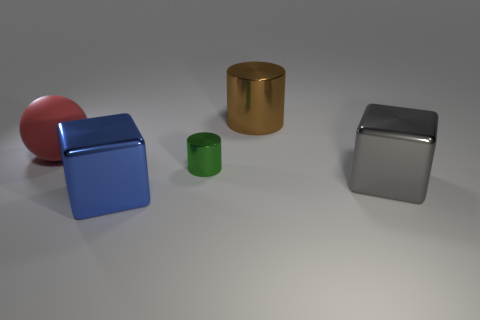Do the blue thing and the big red sphere have the same material?
Your answer should be very brief. No. Are there an equal number of gray metal blocks that are to the left of the large blue thing and red cubes?
Make the answer very short. Yes. What number of other blocks have the same material as the blue block?
Ensure brevity in your answer.  1. Are there fewer brown cylinders than brown shiny spheres?
Provide a succinct answer. No. Do the object that is in front of the gray metallic thing and the large matte ball have the same color?
Your answer should be compact. No. How many large blocks are behind the blue metal thing in front of the metallic thing to the right of the big brown cylinder?
Make the answer very short. 1. There is a big blue metallic thing; what number of large blue objects are to the right of it?
Your answer should be very brief. 0. There is another small object that is the same shape as the brown metallic object; what color is it?
Your response must be concise. Green. What is the big object that is to the left of the small shiny cylinder and to the right of the red sphere made of?
Your answer should be very brief. Metal. There is a object that is on the left side of the blue thing; is its size the same as the green object?
Your response must be concise. No. 